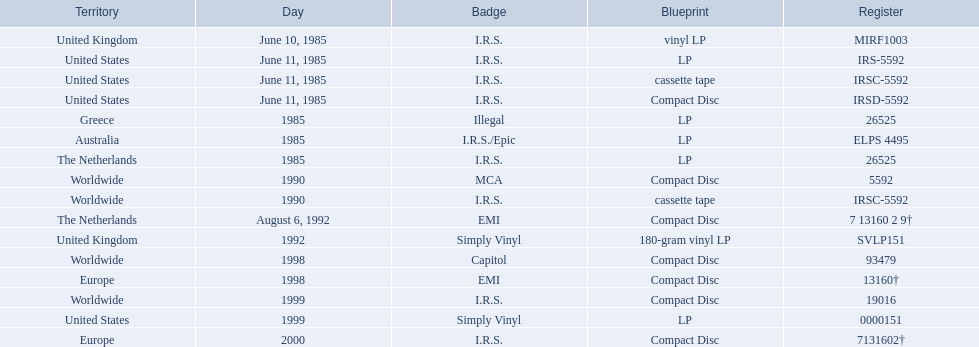Which dates were their releases by fables of the reconstruction? June 10, 1985, June 11, 1985, June 11, 1985, June 11, 1985, 1985, 1985, 1985, 1990, 1990, August 6, 1992, 1992, 1998, 1998, 1999, 1999, 2000. Which of these are in 1985? June 10, 1985, June 11, 1985, June 11, 1985, June 11, 1985, 1985, 1985, 1985. What regions were there releases on these dates? United Kingdom, United States, United States, United States, Greece, Australia, The Netherlands. Which of these are not greece? United Kingdom, United States, United States, United States, Australia, The Netherlands. Which of these regions have two labels listed? Australia. 